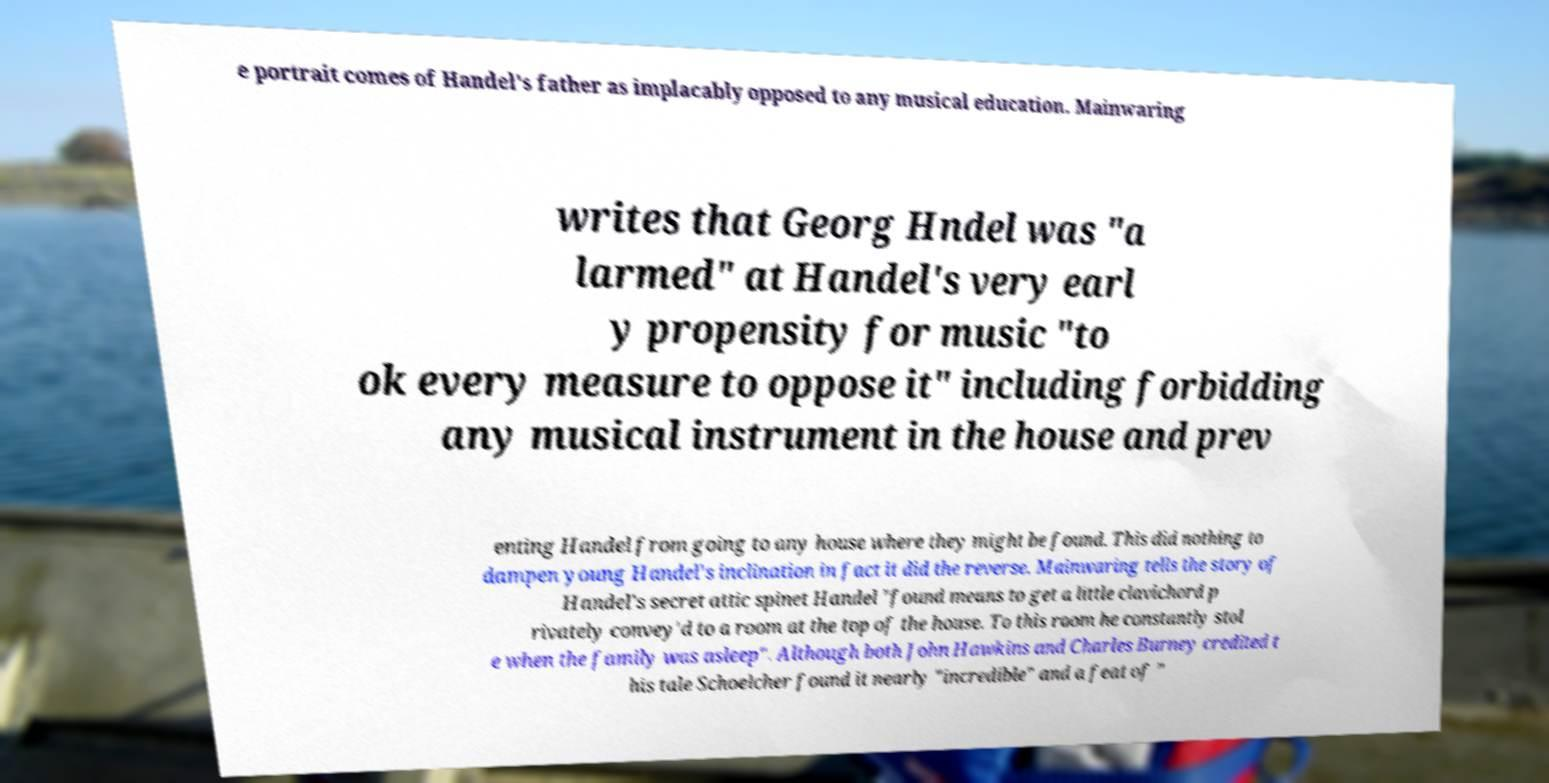Please read and relay the text visible in this image. What does it say? e portrait comes of Handel's father as implacably opposed to any musical education. Mainwaring writes that Georg Hndel was "a larmed" at Handel's very earl y propensity for music "to ok every measure to oppose it" including forbidding any musical instrument in the house and prev enting Handel from going to any house where they might be found. This did nothing to dampen young Handel's inclination in fact it did the reverse. Mainwaring tells the story of Handel's secret attic spinet Handel "found means to get a little clavichord p rivately convey'd to a room at the top of the house. To this room he constantly stol e when the family was asleep". Although both John Hawkins and Charles Burney credited t his tale Schoelcher found it nearly "incredible" and a feat of " 